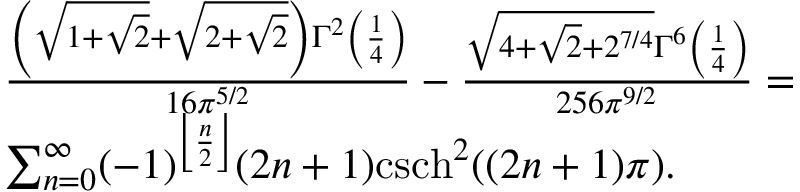<formula> <loc_0><loc_0><loc_500><loc_500>\begin{array} { r l } & { \frac { \left ( \sqrt { 1 + \sqrt { 2 } } + \sqrt { 2 + \sqrt { 2 } } \right ) \Gamma ^ { 2 } \left ( \frac { 1 } { 4 } \right ) } { 1 6 \pi ^ { 5 / 2 } } - \frac { \sqrt { 4 + \sqrt { 2 } + 2 ^ { 7 / 4 } } \Gamma ^ { 6 } \left ( \frac { 1 } { 4 } \right ) } { 2 5 6 \pi ^ { 9 / 2 } } = } \\ & { \sum _ { n = 0 } ^ { \infty } ( - 1 ) ^ { \left \lfloor \frac { n } { 2 } \right \rfloor } ( 2 n + 1 ) c s c h ^ { 2 } ( ( 2 n + 1 ) \pi ) . } \end{array}</formula> 